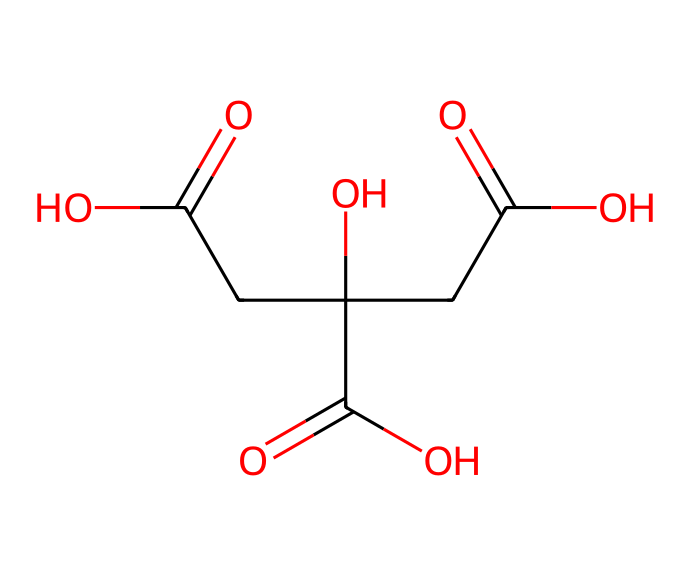How many carbon atoms are in citric acid? By analyzing the SMILES representation, we can count the number of carbon atoms represented by 'C'. In the structure, there are six carbon atoms depicted.
Answer: six What functional groups are present in citric acid? Looking closely at the SMILES representation, we see multiple occurrences of 'C(=O)' indicating carboxylic acid groups. Additionally, 'C(O)' shows the presence of a hydroxyl group. Thus, citric acid contains carboxylic acids and a hydroxyl group.
Answer: carboxylic acid, hydroxyl What is the total number of hydrogen atoms in citric acid? Each carbon and oxygen atom in the chemical structure helps determine the number of associated hydrogen atoms. In this case, total hydrogens can be counted to be eight after analyzing single bonds and hydrogen saturation.
Answer: eight How many double bonds are found in citric acid? In the provided SMILES, there are multiple instances of the '=' sign, indicating double bonds. Upon closer examination, we find that there are three double bonds in the structure.
Answer: three Is citric acid a saturated or unsaturated compound? Looking at the presence of double bonds in the chemical structure, we can conclude that citric acid, with its multiple double bonds, is classified as an unsaturated compound.
Answer: unsaturated What type of isomerism can citric acid exhibit? Analyzing the structure indicates that citric acid has stereocenters, which allows for geometric (cis-trans) and optical isomerism due to the presence of its chiral centers.
Answer: stereoisomerism How does the presence of carboxylic groups affect the acidity of citric acid? The presence of multiple carboxylic acid groups in the structure increases the ability of citric acid to donate protons (H+), thus increasing its acidity compared to aliphatic compounds containing only alkanes.
Answer: increases acidity 